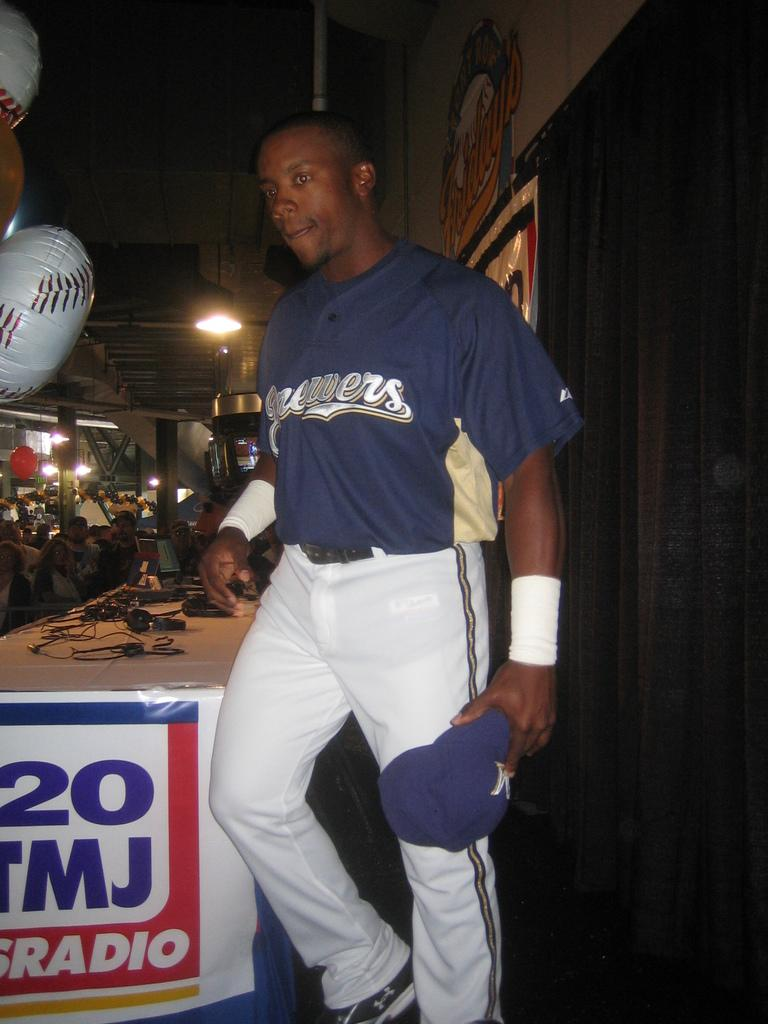<image>
Present a compact description of the photo's key features. Black baseball player for the Brewers standing beside a table. 